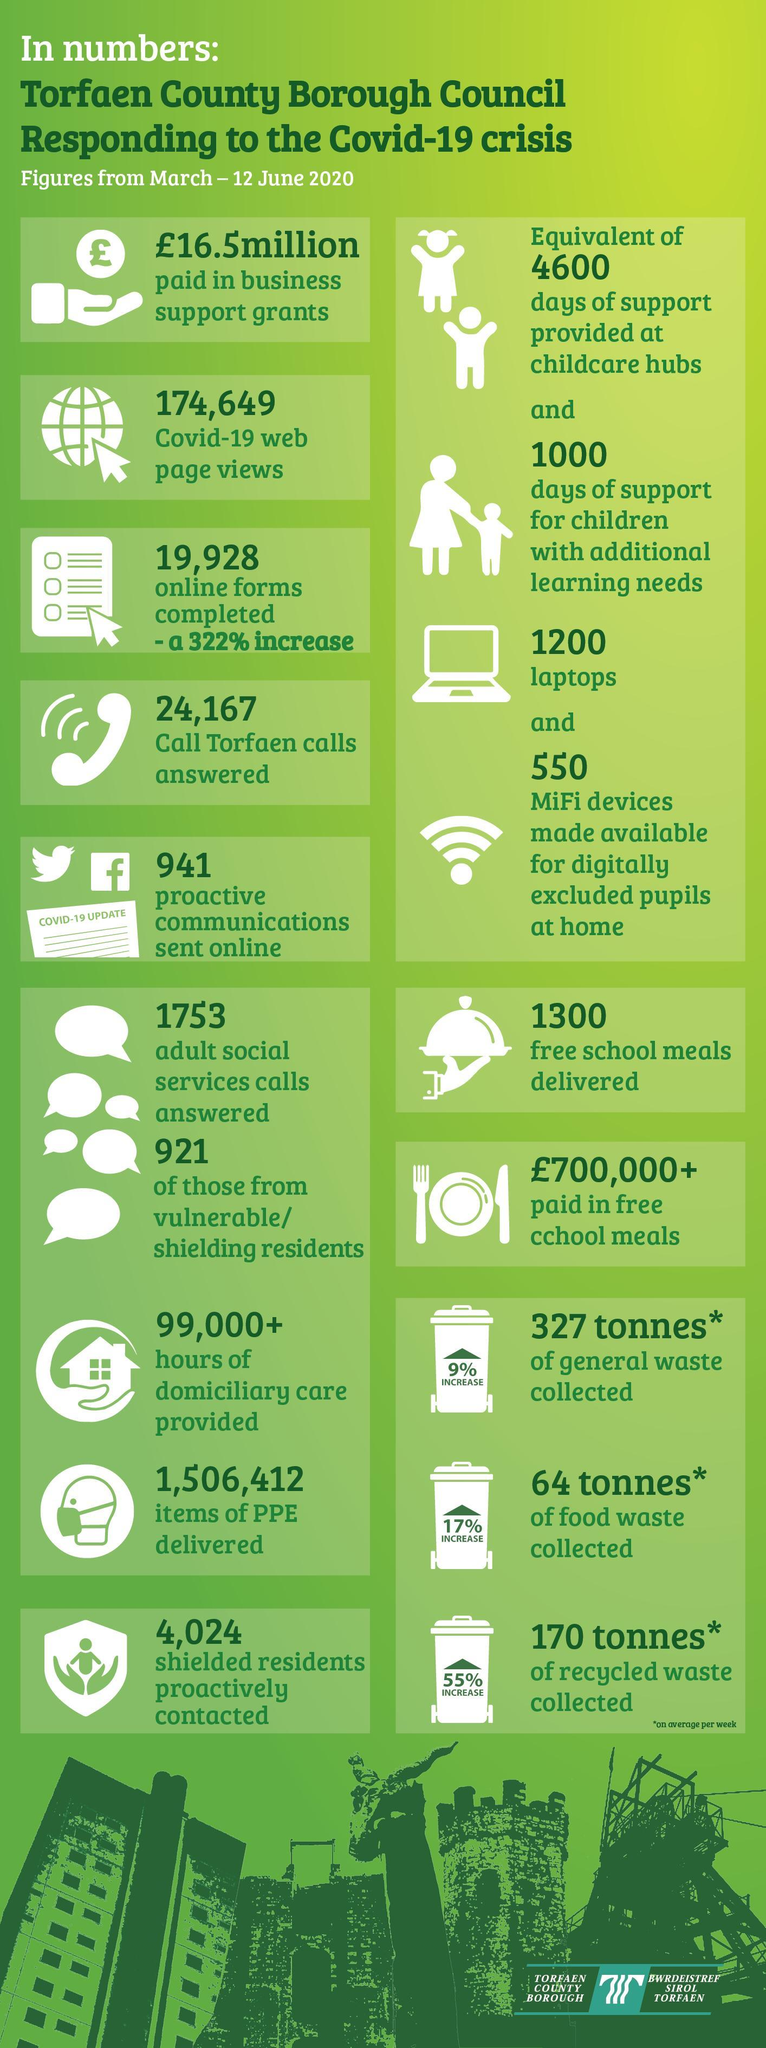How many people have viewed the Torfaen County Borough Council web page during Corona crisis?
Answer the question with a short phrase. 174,649 What support has been provided by Torfaen Council for the children with extra educational needs? 1000 days of support How much PPE kits were delivered during Covid-19 crisis by the Torfaen Council? 1,506,412 How many social services calls has been answered during Covid-19 crisis by Torfaen Council? 1753 What quantity of general garbage was moved by Torfaen Council during Covid-19 crisis? 327 tonnes How many free school food packets were supplied by Torfaen Council during Covid-19 crisis? 1300 